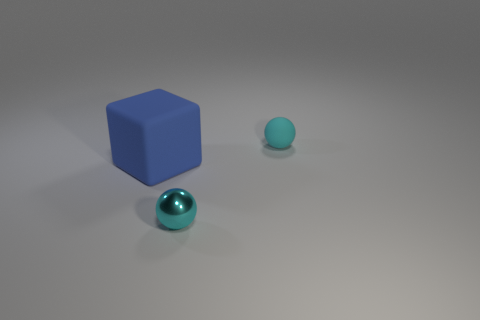Add 1 big gray rubber spheres. How many objects exist? 4 Subtract all blocks. How many objects are left? 2 Subtract 0 cyan cubes. How many objects are left? 3 Subtract all red objects. Subtract all cyan objects. How many objects are left? 1 Add 3 cyan balls. How many cyan balls are left? 5 Add 1 small purple metal cylinders. How many small purple metal cylinders exist? 1 